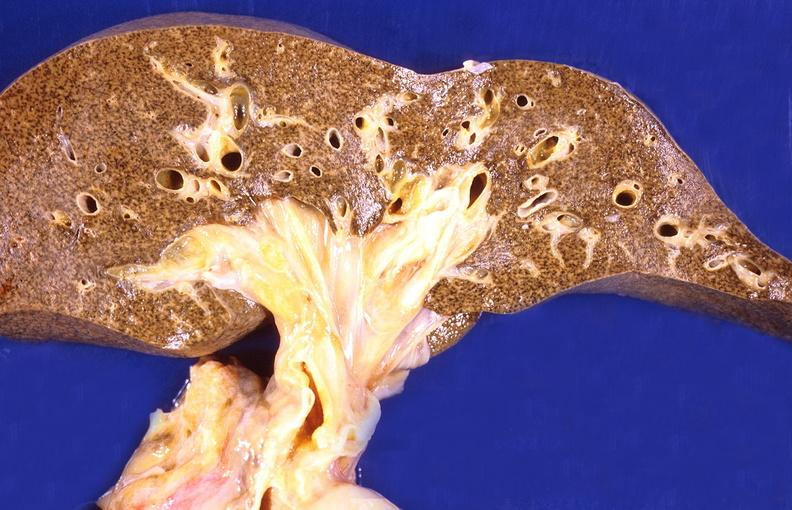what does this image show?
Answer the question using a single word or phrase. Cirrhosis 